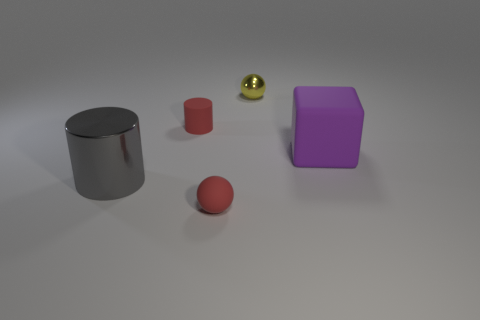Add 4 large purple blocks. How many large purple blocks are left? 5 Add 4 small green matte cylinders. How many small green matte cylinders exist? 4 Add 1 large cubes. How many objects exist? 6 Subtract all yellow balls. How many balls are left? 1 Subtract 1 yellow balls. How many objects are left? 4 Subtract all spheres. How many objects are left? 3 Subtract 1 spheres. How many spheres are left? 1 Subtract all purple spheres. Subtract all blue cylinders. How many spheres are left? 2 Subtract all gray spheres. How many brown cylinders are left? 0 Subtract all shiny spheres. Subtract all small yellow spheres. How many objects are left? 3 